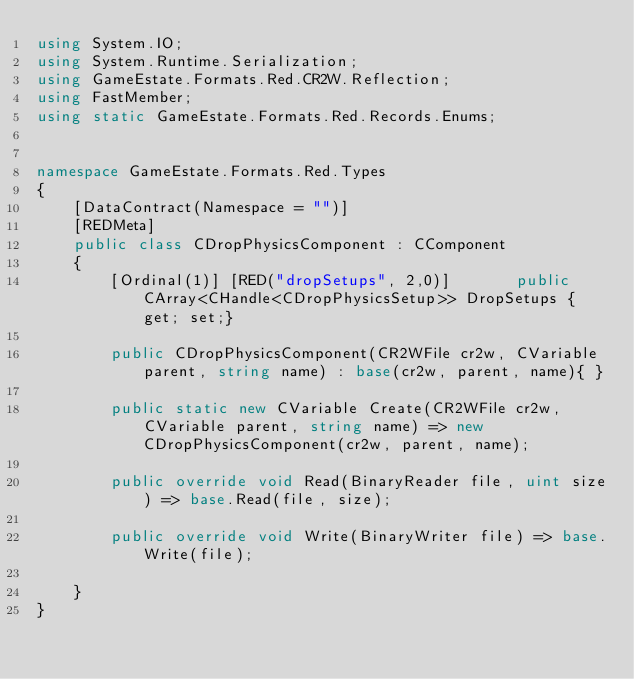<code> <loc_0><loc_0><loc_500><loc_500><_C#_>using System.IO;
using System.Runtime.Serialization;
using GameEstate.Formats.Red.CR2W.Reflection;
using FastMember;
using static GameEstate.Formats.Red.Records.Enums;


namespace GameEstate.Formats.Red.Types
{
	[DataContract(Namespace = "")]
	[REDMeta]
	public class CDropPhysicsComponent : CComponent
	{
		[Ordinal(1)] [RED("dropSetups", 2,0)] 		public CArray<CHandle<CDropPhysicsSetup>> DropSetups { get; set;}

		public CDropPhysicsComponent(CR2WFile cr2w, CVariable parent, string name) : base(cr2w, parent, name){ }

		public static new CVariable Create(CR2WFile cr2w, CVariable parent, string name) => new CDropPhysicsComponent(cr2w, parent, name);

		public override void Read(BinaryReader file, uint size) => base.Read(file, size);

		public override void Write(BinaryWriter file) => base.Write(file);

	}
}</code> 